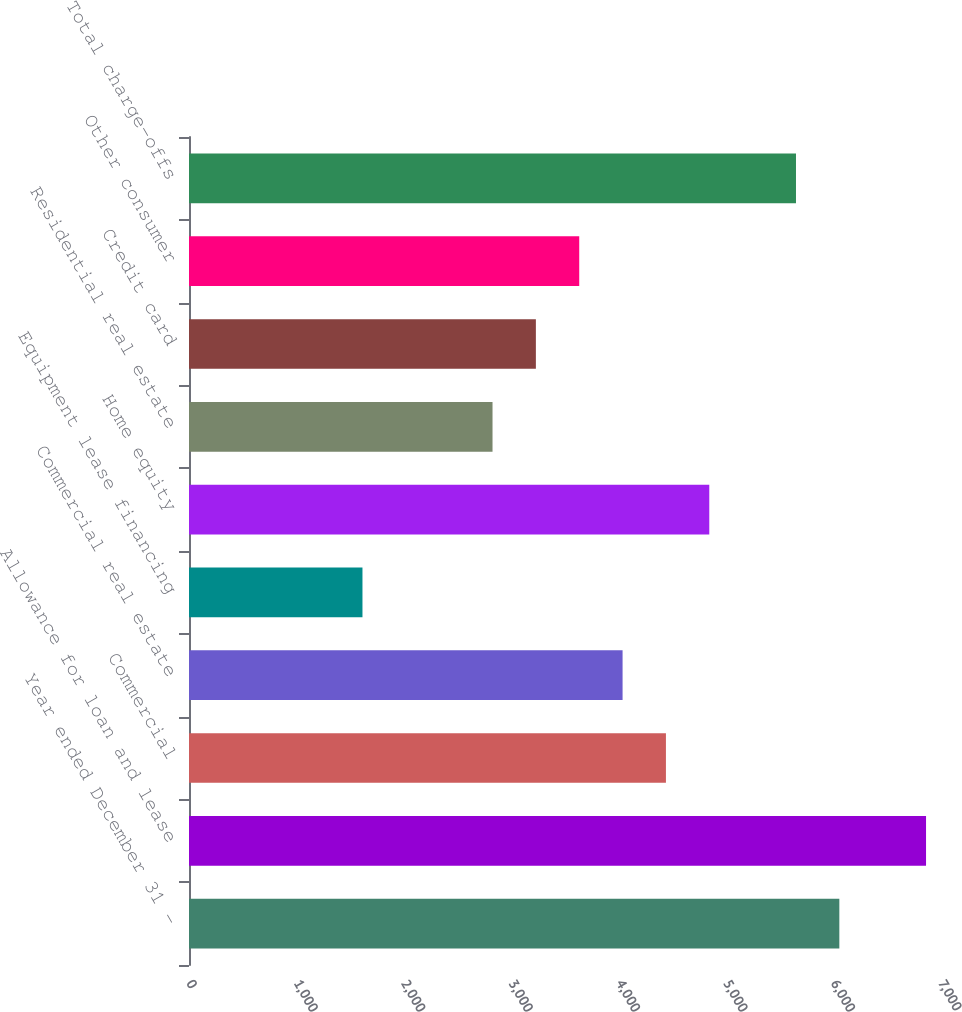Convert chart to OTSL. <chart><loc_0><loc_0><loc_500><loc_500><bar_chart><fcel>Year ended December 31 -<fcel>Allowance for loan and lease<fcel>Commercial<fcel>Commercial real estate<fcel>Equipment lease financing<fcel>Home equity<fcel>Residential real estate<fcel>Credit card<fcel>Other consumer<fcel>Total charge-offs<nl><fcel>6053.67<fcel>6860.75<fcel>4439.51<fcel>4035.97<fcel>1614.73<fcel>4843.05<fcel>2825.35<fcel>3228.89<fcel>3632.43<fcel>5650.13<nl></chart> 